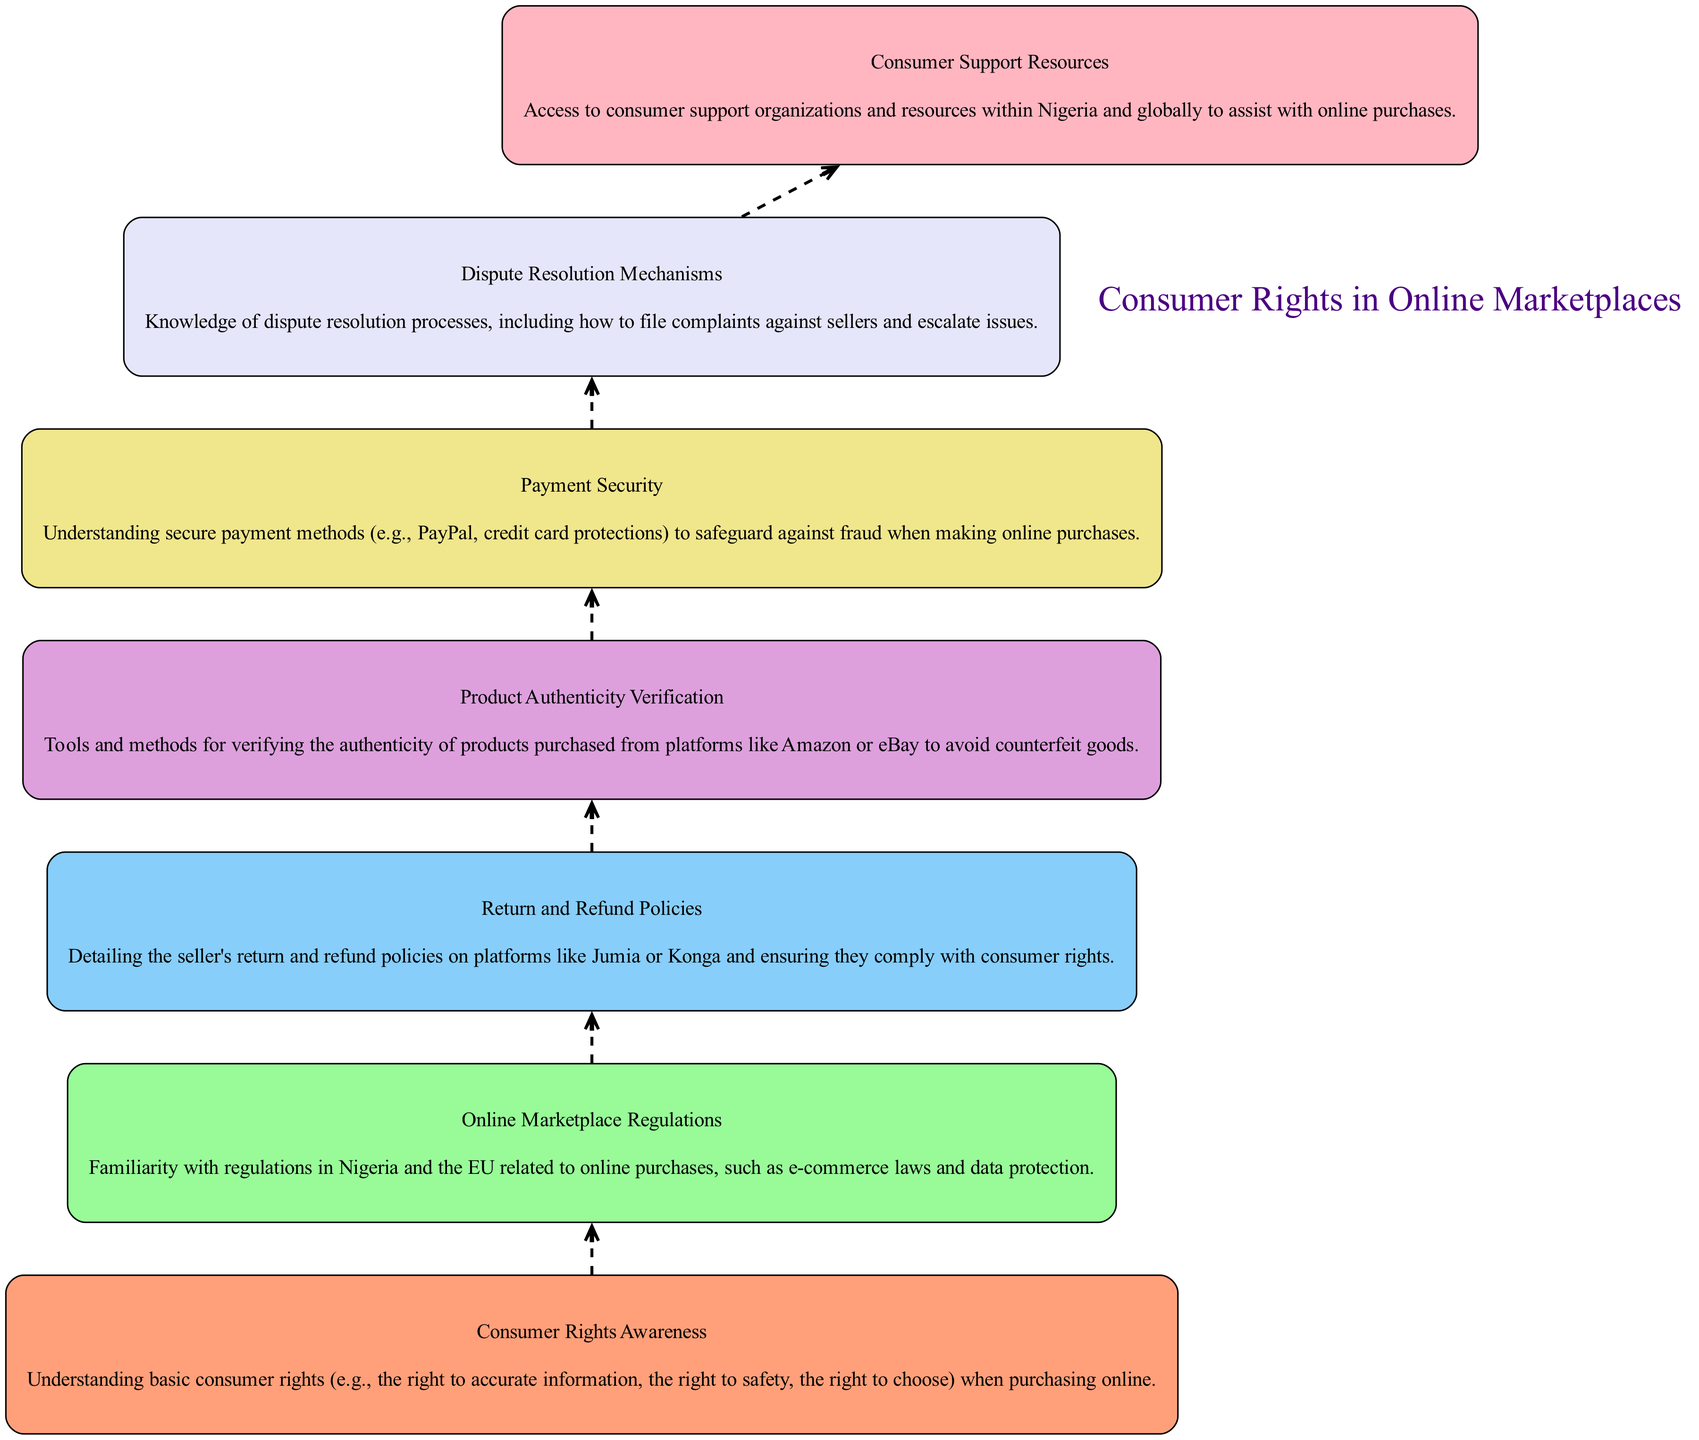What is the first element in the diagram? The first element in the diagram is "Consumer Rights Awareness," which is listed at the top of the flow chart.
Answer: Consumer Rights Awareness How many elements are there in total? Counting all the nodes in the diagram, there are a total of 7 elements represented.
Answer: 7 What is the last node in the flow chart? The last node in the flow chart is "Consumer Support Resources," indicating the final step in the analysis process.
Answer: Consumer Support Resources What is described under "Payment Security"? "Payment Security" includes understanding secure payment methods like PayPal and credit card protections to safeguard against fraud.
Answer: Understanding secure payment methods Which two elements are directly connected? "Online Marketplace Regulations" and "Return and Refund Policies" are directly connected, indicating a sequential flow from one to the other.
Answer: Online Marketplace Regulations and Return and Refund Policies How does "Consumer Rights Awareness" relate to "Dispute Resolution Mechanisms"? "Consumer Rights Awareness" informs the understanding of "Dispute Resolution Mechanisms," as being aware of consumer rights is crucial for resolving issues with sellers.
Answer: Understanding of consumer rights is crucial for resolving issues What color is "Product Authenticity Verification"? "Product Authenticity Verification" is displayed in a light blue color, representing the fourth element in the color palette used in the diagram.
Answer: Light blue Which element comes immediately before "Consumer Support Resources"? The element that comes immediately before "Consumer Support Resources" is "Dispute Resolution Mechanisms," showing a progression in the flow of consumer rights analysis.
Answer: Dispute Resolution Mechanisms 